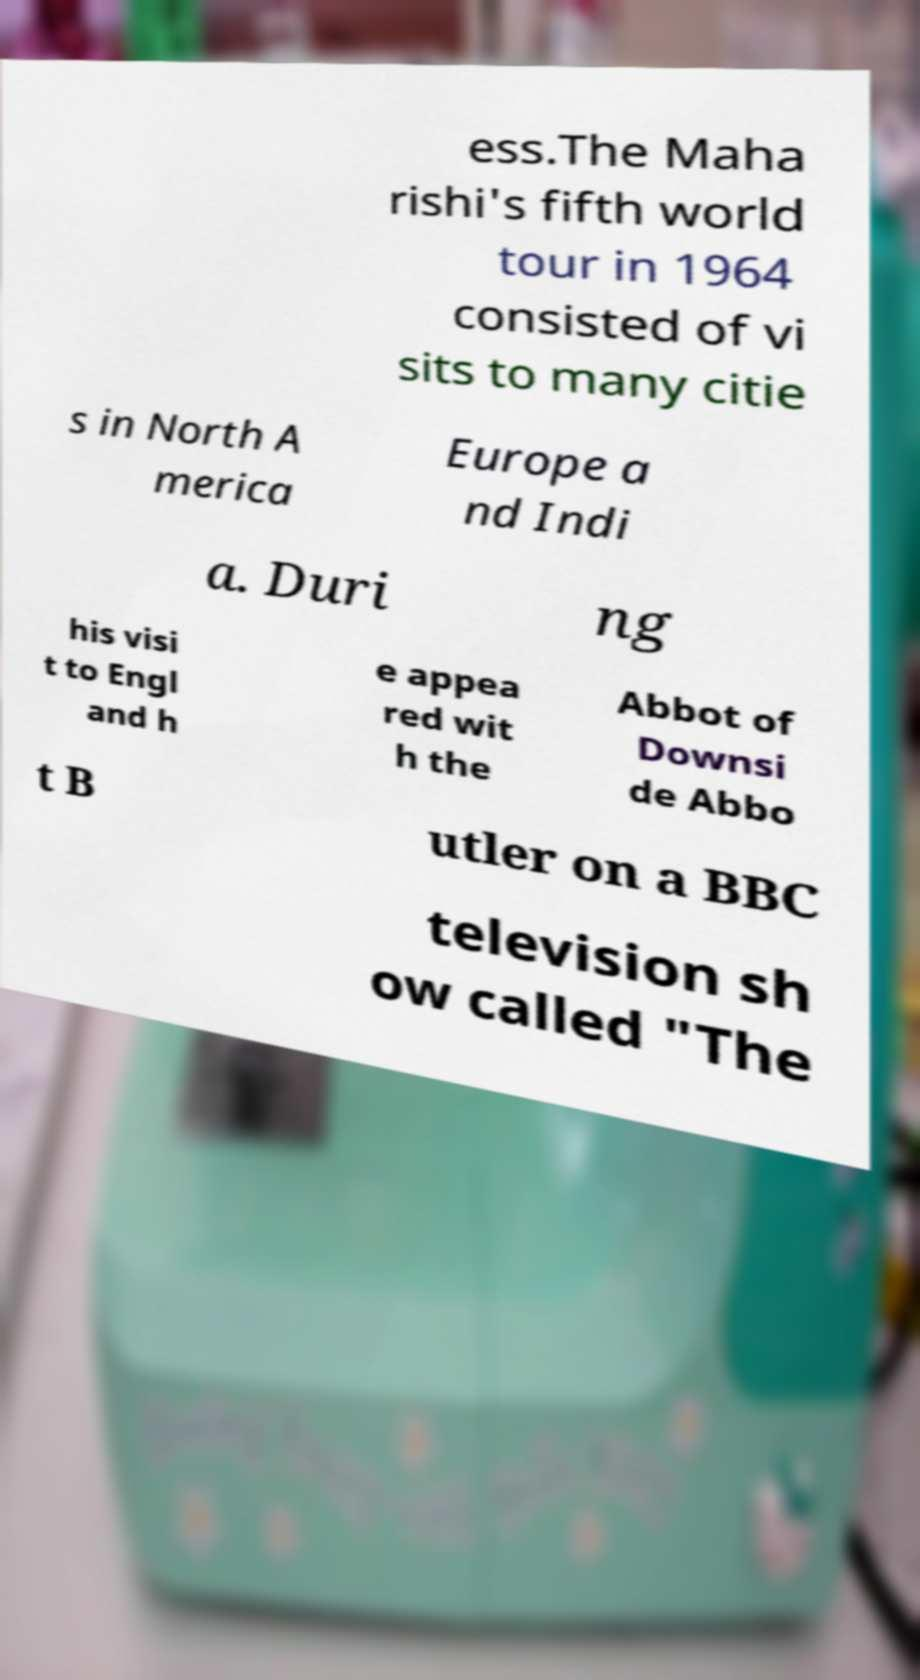Please identify and transcribe the text found in this image. ess.The Maha rishi's fifth world tour in 1964 consisted of vi sits to many citie s in North A merica Europe a nd Indi a. Duri ng his visi t to Engl and h e appea red wit h the Abbot of Downsi de Abbo t B utler on a BBC television sh ow called "The 